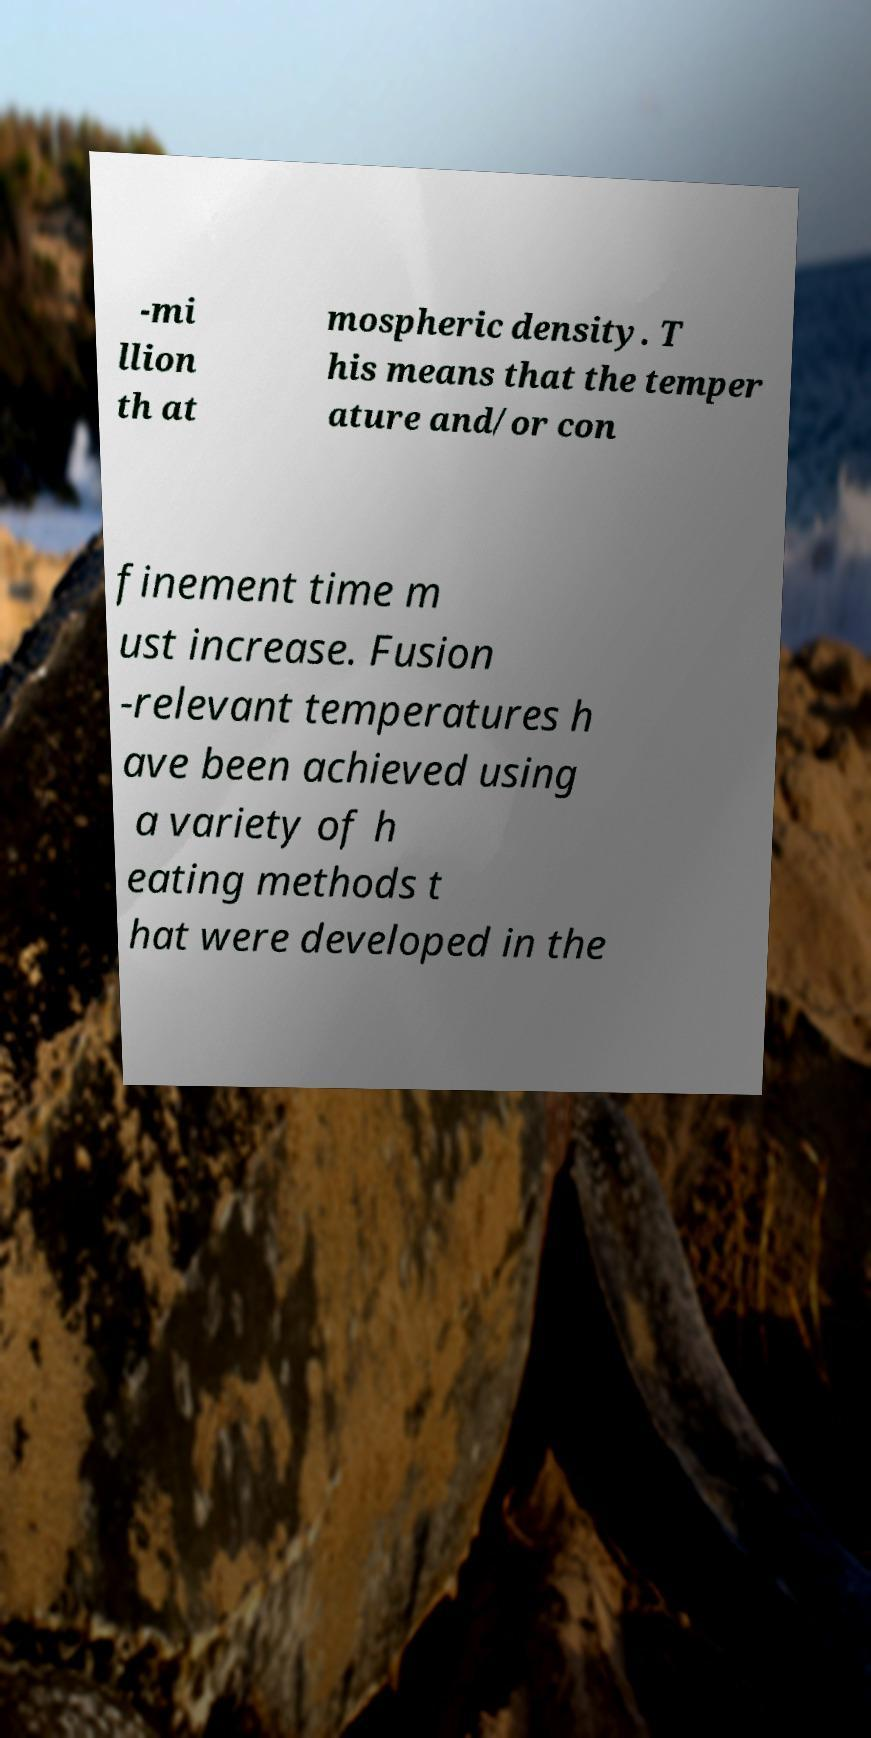Can you accurately transcribe the text from the provided image for me? -mi llion th at mospheric density. T his means that the temper ature and/or con finement time m ust increase. Fusion -relevant temperatures h ave been achieved using a variety of h eating methods t hat were developed in the 